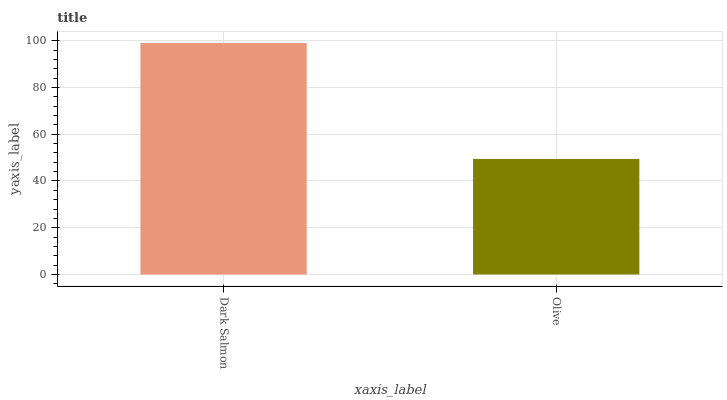Is Olive the minimum?
Answer yes or no. Yes. Is Dark Salmon the maximum?
Answer yes or no. Yes. Is Olive the maximum?
Answer yes or no. No. Is Dark Salmon greater than Olive?
Answer yes or no. Yes. Is Olive less than Dark Salmon?
Answer yes or no. Yes. Is Olive greater than Dark Salmon?
Answer yes or no. No. Is Dark Salmon less than Olive?
Answer yes or no. No. Is Dark Salmon the high median?
Answer yes or no. Yes. Is Olive the low median?
Answer yes or no. Yes. Is Olive the high median?
Answer yes or no. No. Is Dark Salmon the low median?
Answer yes or no. No. 